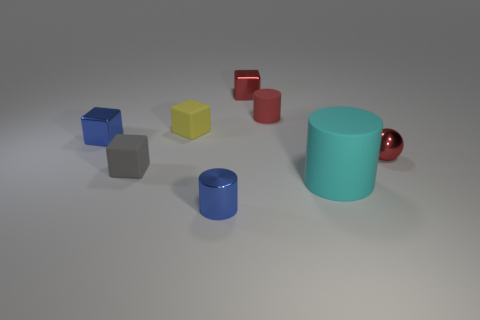What number of rubber cylinders are the same color as the small metal ball?
Your answer should be very brief. 1. What is the size of the matte cylinder in front of the blue cube?
Provide a short and direct response. Large. How many tiny objects are either blue metal cylinders or gray rubber things?
Make the answer very short. 2. The shiny thing that is behind the blue shiny cylinder and on the left side of the tiny red metallic cube is what color?
Your answer should be compact. Blue. Are there any red objects that have the same shape as the cyan matte thing?
Your answer should be compact. Yes. What material is the small gray block?
Your response must be concise. Rubber. Are there any matte cylinders behind the gray matte cube?
Ensure brevity in your answer.  Yes. Is the shape of the large rubber object the same as the yellow matte object?
Provide a succinct answer. No. How many other things are the same size as the yellow matte block?
Your answer should be compact. 6. What number of objects are either small red shiny cubes that are behind the big cyan thing or brown metal objects?
Ensure brevity in your answer.  1. 